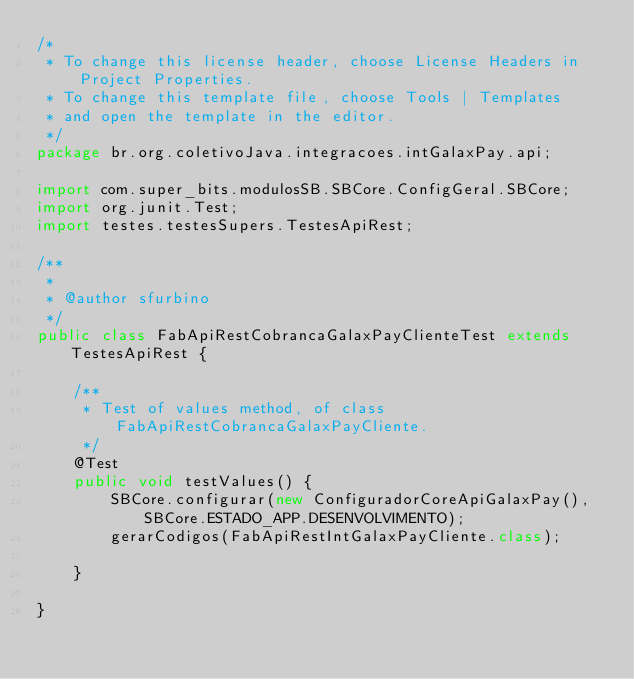<code> <loc_0><loc_0><loc_500><loc_500><_Java_>/*
 * To change this license header, choose License Headers in Project Properties.
 * To change this template file, choose Tools | Templates
 * and open the template in the editor.
 */
package br.org.coletivoJava.integracoes.intGalaxPay.api;

import com.super_bits.modulosSB.SBCore.ConfigGeral.SBCore;
import org.junit.Test;
import testes.testesSupers.TestesApiRest;

/**
 *
 * @author sfurbino
 */
public class FabApiRestCobrancaGalaxPayClienteTest extends TestesApiRest {

    /**
     * Test of values method, of class FabApiRestCobrancaGalaxPayCliente.
     */
    @Test
    public void testValues() {
        SBCore.configurar(new ConfiguradorCoreApiGalaxPay(), SBCore.ESTADO_APP.DESENVOLVIMENTO);
        gerarCodigos(FabApiRestIntGalaxPayCliente.class);

    }

}
</code> 